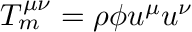<formula> <loc_0><loc_0><loc_500><loc_500>T _ { m } ^ { \mu \nu } = \rho \phi u ^ { \mu } u ^ { \nu }</formula> 